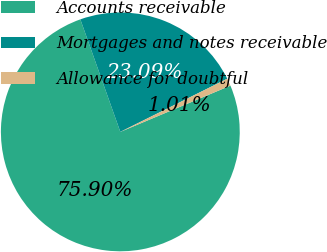<chart> <loc_0><loc_0><loc_500><loc_500><pie_chart><fcel>Accounts receivable<fcel>Mortgages and notes receivable<fcel>Allowance for doubtful<nl><fcel>75.9%<fcel>23.09%<fcel>1.01%<nl></chart> 